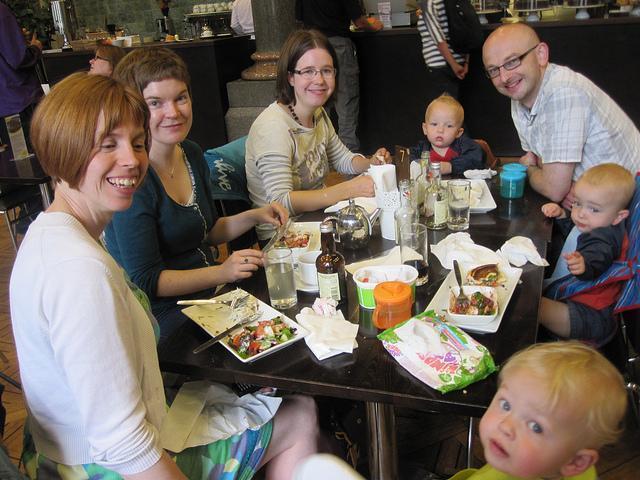How many children are there?
Give a very brief answer. 3. How many people are wearing glasses in this scene?
Give a very brief answer. 2. How many women are at the table?
Give a very brief answer. 3. How many men in the photo?
Give a very brief answer. 1. How many dining tables are in the photo?
Give a very brief answer. 3. How many chairs are in the photo?
Give a very brief answer. 3. How many people are there?
Give a very brief answer. 10. 